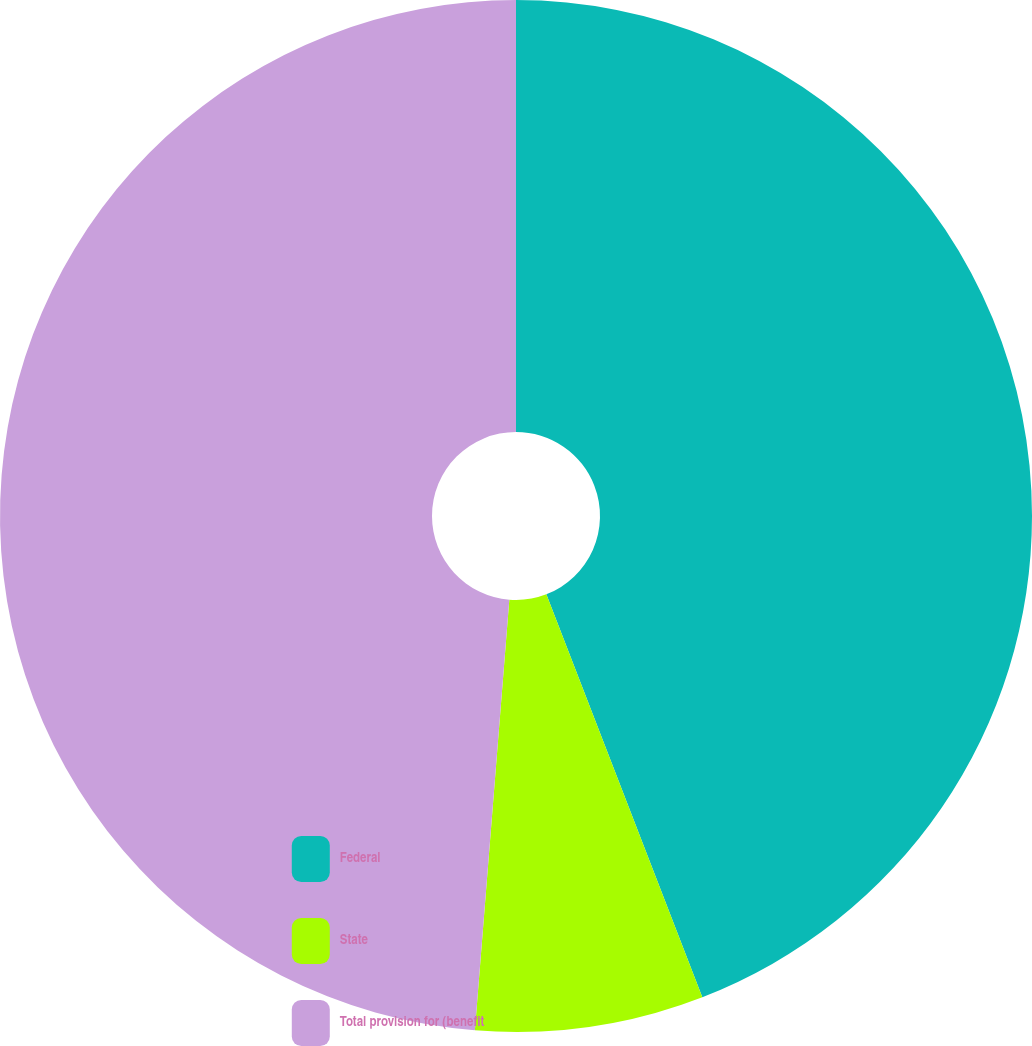Convert chart. <chart><loc_0><loc_0><loc_500><loc_500><pie_chart><fcel>Federal<fcel>State<fcel>Total provision for (benefit<nl><fcel>44.12%<fcel>7.15%<fcel>48.73%<nl></chart> 